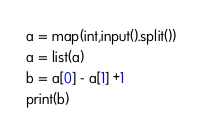Convert code to text. <code><loc_0><loc_0><loc_500><loc_500><_Python_>a = map(int,input().split())
a = list(a)
b = a[0] - a[1] +1
print(b)</code> 